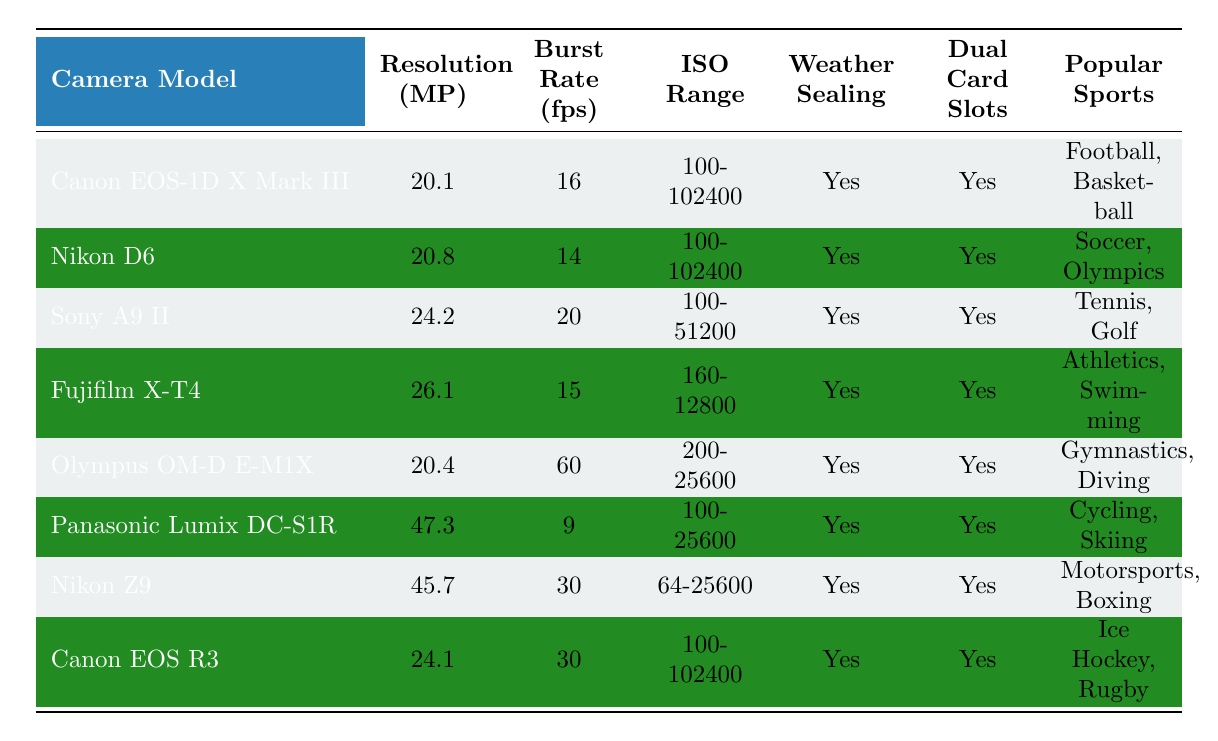What is the ISO range of the Canon EOS-1D X Mark III? By locating the Canon EOS-1D X Mark III in the table, we can find its ISO range listed directly under that camera model, which is 100-102400.
Answer: 100-102400 Which camera model has the highest resolution? By scanning through the "Resolution (MP)" column, we see that the Panasonic Lumix DC-S1R has the highest resolution value, which is 47.3 megapixels.
Answer: Panasonic Lumix DC-S1R How many camera models have a burst rate of 30 fps or higher? Counting the camera models listed with a burst rate of 30 fps or above, we find the Nikon Z9 and Canon EOS R3, making a total of 2 camera models.
Answer: 2 What is the difference in resolution between the Nikon D6 and the Sony A9 II? The resolution of the Nikon D6 is 20.8 MP and the resolution of the Sony A9 II is 24.2 MP. To find the difference, we subtract the D6's resolution from the A9 II's resolution, which equals 24.2 - 20.8 = 3.4 MP.
Answer: 3.4 MP Which cameras are suitable for gymnastics or diving? By reviewing the "Popular Sports" column, the Olympus OM-D E-M1X is listed as suitable for gymnastics and diving. This can be determined by directly looking at the corresponding row for the camera.
Answer: Olympus OM-D E-M1X Is the Nikon Z9 weather-sealed? To find out if the Nikon Z9 is weather-sealed, we check the corresponding entry in the "Weather Sealing" column, where it is marked as "Yes."
Answer: Yes How many camera models support dual card slots and have a burst rate below 15 fps? Checking both the "Dual Card Slots" and "Burst Rate (fps)" columns, we note that all camera models listed have dual card slots, but only the Panasonic Lumix DC-S1R with a burst rate of 9 fps fits the criteria. Thus, there is only 1 model.
Answer: 1 What popular sports are covered by cameras with resolutions over 25 MP? Assessing the "Popular Sports" column for camera models with resolutions greater than 25 MP, which are the Sony A9 II, Fujifilm X-T4, Panasonic Lumix DC-S1R, and Nikon Z9, we find the corresponding sports are Tennis, Golf, Athletics, Swimming, Cycling, Skiing, and Motorsports, Boxing.
Answer: Tennis, Golf; Athletics, Swimming; Cycling, Skiing; Motorsports, Boxing Are there any camera models suitable for ice hockey? Looking under the "Popular Sports" column by identifying whether any camera lists ice hockey, we confirm that the Canon EOS R3 is listed as suitable for ice hockey.
Answer: Yes Which camera has the lowest burst rate and what is it? By scanning the "Burst Rate (fps)" column, we find the Panasonic Lumix DC-S1R with a burst rate of 9 fps, which is the lowest among the listed models.
Answer: Panasonic Lumix DC-S1R and 9 fps 